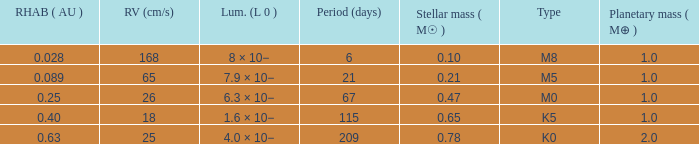What is the highest planetary mass having an RV (cm/s) of 65 and a Period (days) less than 21? None. 